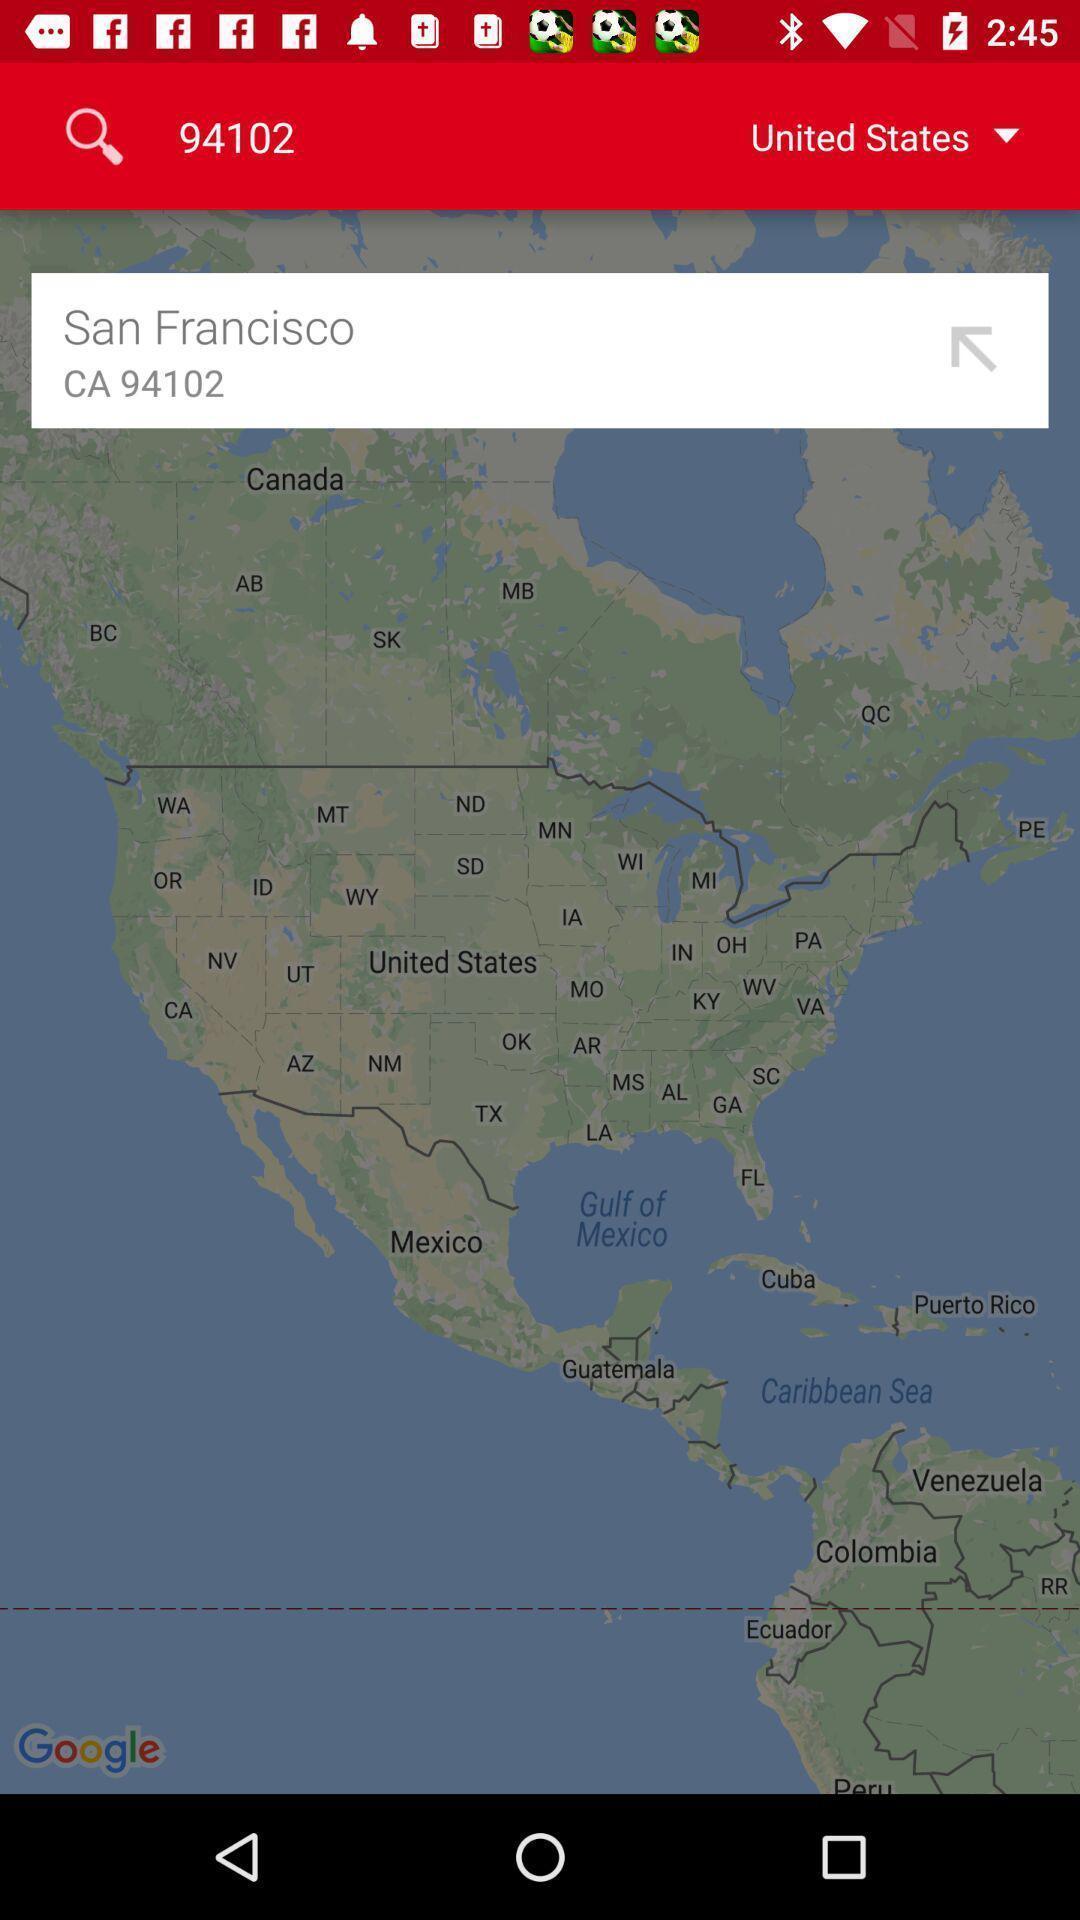Explain the elements present in this screenshot. Search bar to find location of an navigation app. 